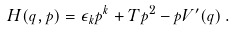<formula> <loc_0><loc_0><loc_500><loc_500>H ( q , p ) = \epsilon _ { k } p ^ { k } + T p ^ { 2 } - p V ^ { \prime } ( q ) \, .</formula> 